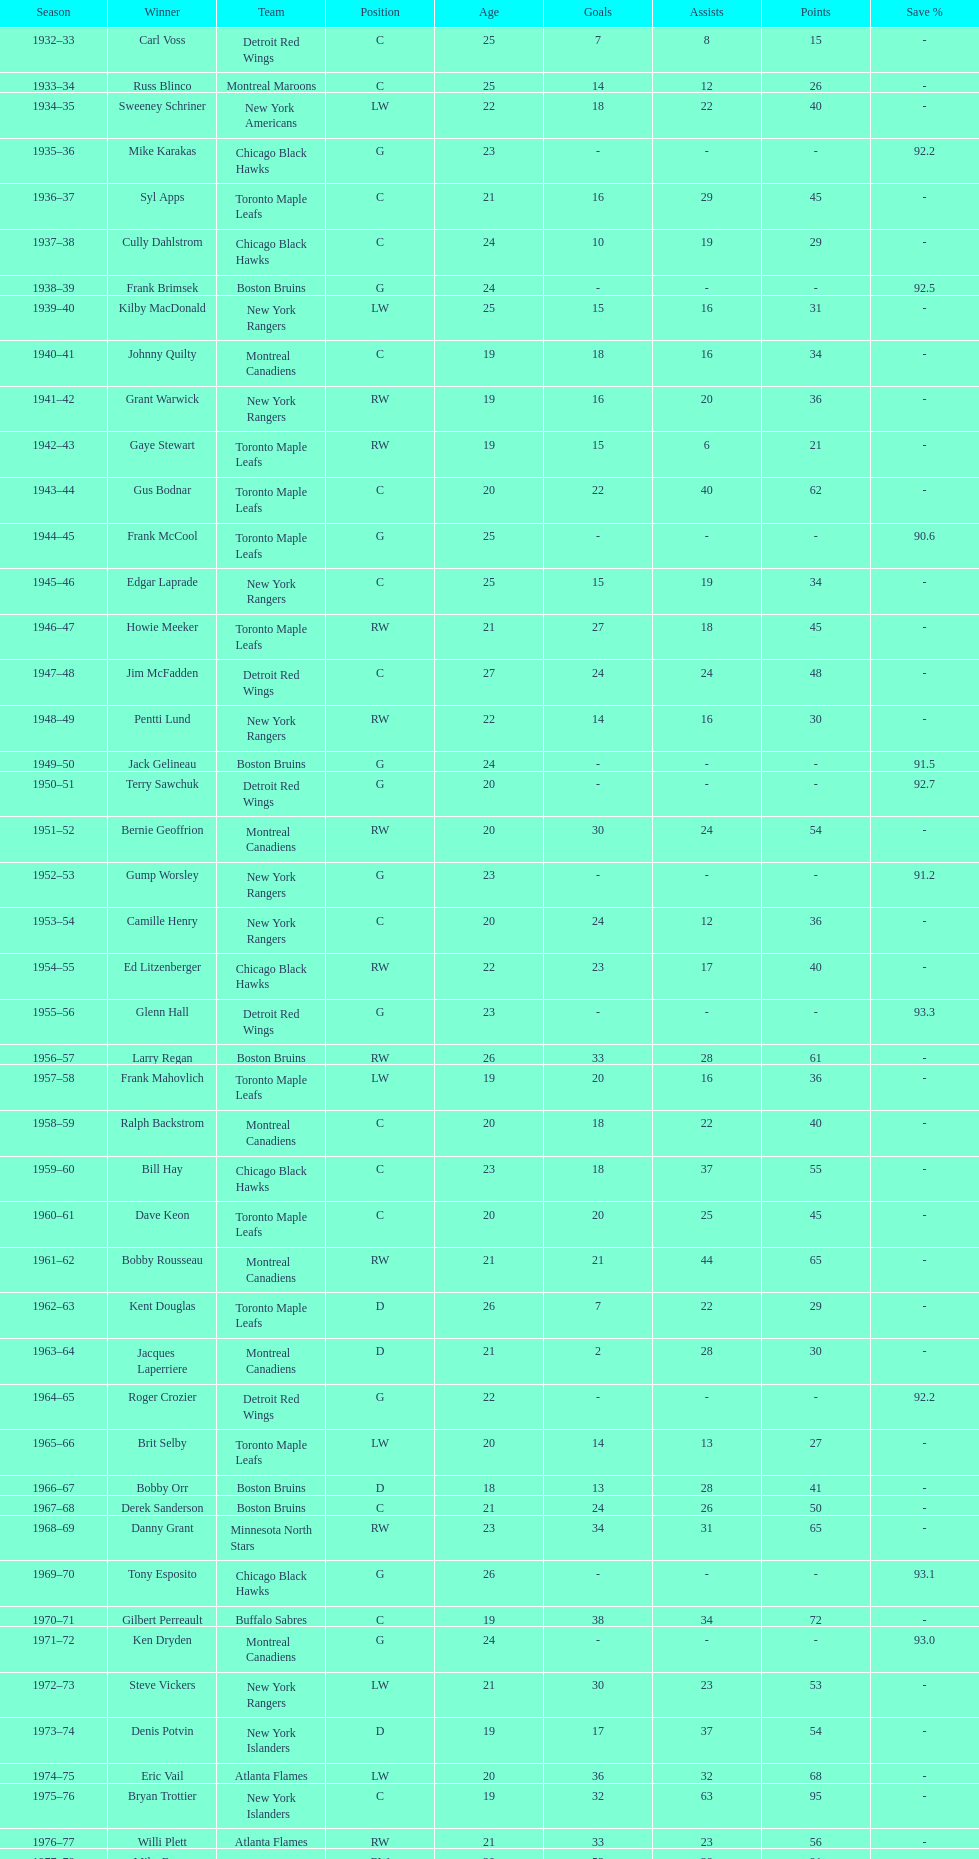How many times did the toronto maple leaves win? 9. 